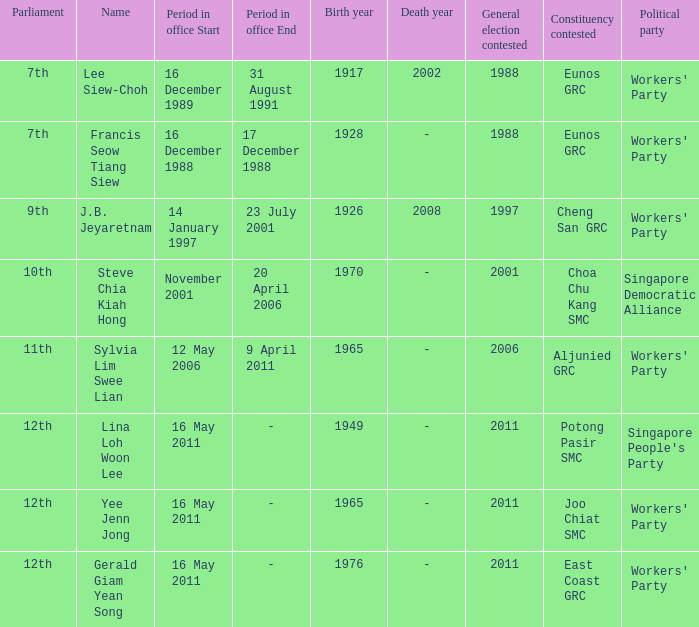Which parliament is sylvia lim swee lian? 11th. 